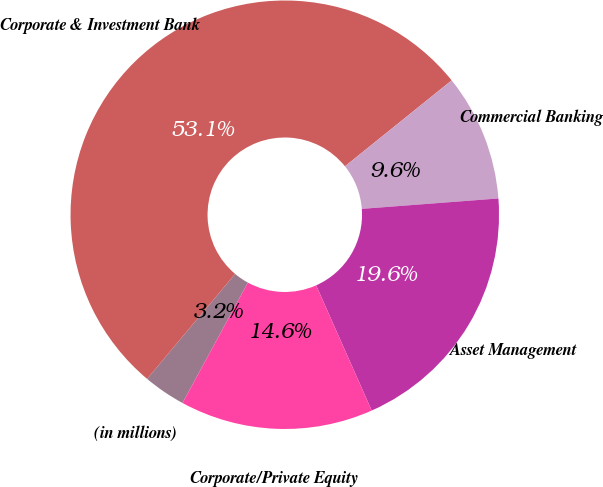Convert chart to OTSL. <chart><loc_0><loc_0><loc_500><loc_500><pie_chart><fcel>(in millions)<fcel>Corporate & Investment Bank<fcel>Commercial Banking<fcel>Asset Management<fcel>Corporate/Private Equity<nl><fcel>3.19%<fcel>53.1%<fcel>9.58%<fcel>19.56%<fcel>14.57%<nl></chart> 